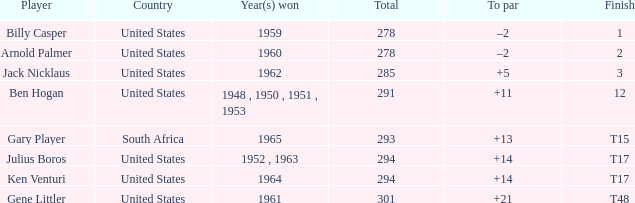What is the finish designation when the nation is "united states" and to par is set to "+21"? T48. 